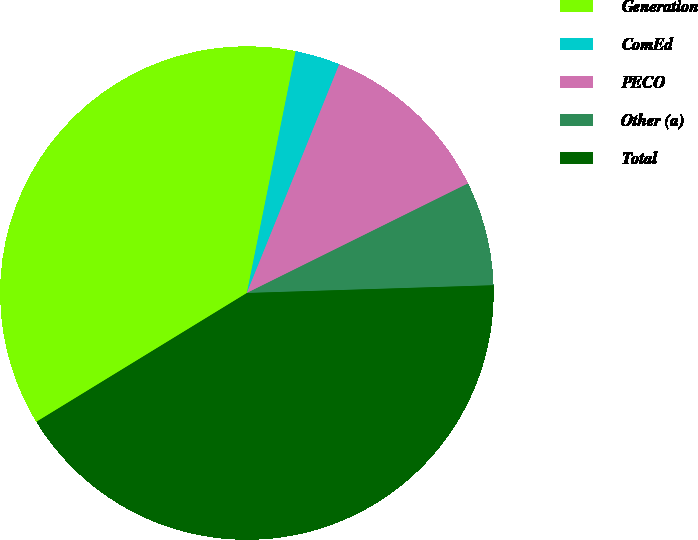Convert chart to OTSL. <chart><loc_0><loc_0><loc_500><loc_500><pie_chart><fcel>Generation<fcel>ComEd<fcel>PECO<fcel>Other (a)<fcel>Total<nl><fcel>36.91%<fcel>2.94%<fcel>11.57%<fcel>6.82%<fcel>41.76%<nl></chart> 